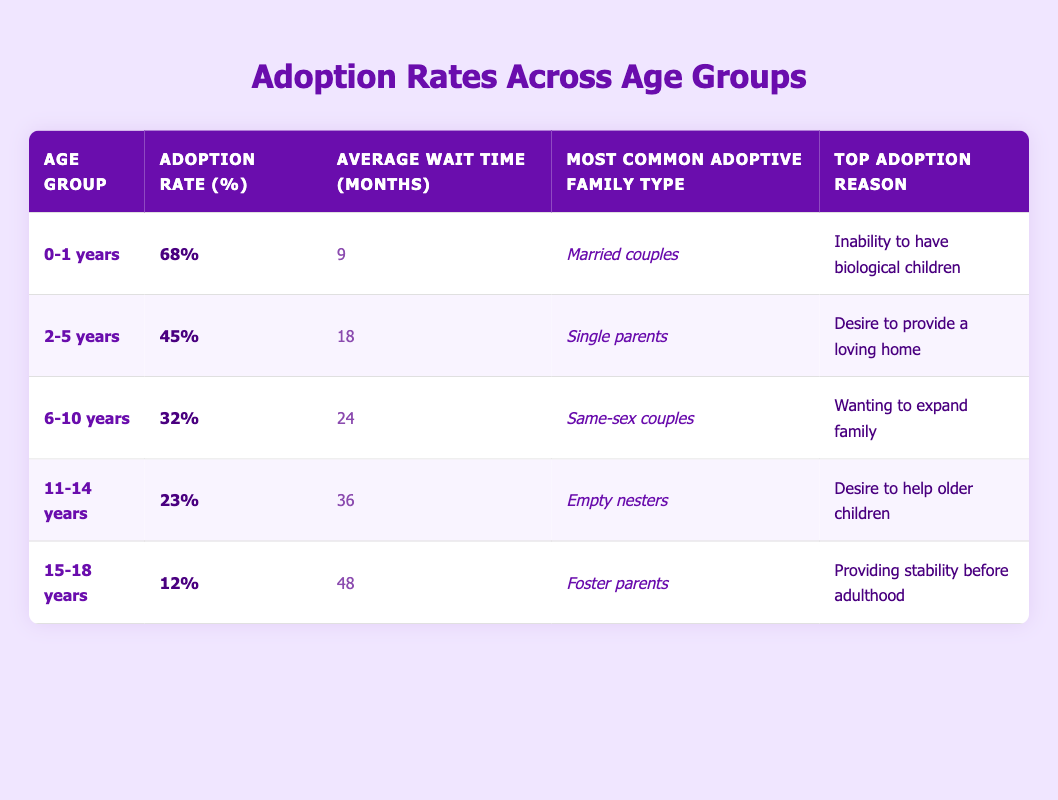What is the adoption rate for children aged 0-1 years? The adoption rate for the age group 0-1 years is shown in the table under the "Adoption Rate (%)" column in the corresponding row. It states 68%.
Answer: 68% Which age group has the highest adoption rate? By comparing the "Adoption Rate (%)" values in the table, the age group 0-1 years has the highest rate at 68%.
Answer: 0-1 years What is the average wait time for adopting a child aged 6-10 years? The table provides the "Average Wait Time (months)" for the age group 6-10 years in the corresponding row, which is 24 months.
Answer: 24 months Is the most common adoptive family type for children aged 2-5 years single parents? The table specifies the "Most Common Adoptive Family Type" for the age group 2-5 years, which lists single parents. Thus, the statement is true.
Answer: Yes Calculate the average adoption rate for children aged 11-14 years and 15-18 years. The adoption rates for these age groups are 23% for 11-14 years and 12% for 15-18 years. To find the average, sum the rates (23 + 12) = 35 and divide by the number of groups (2): 35/2 = 17.5%.
Answer: 17.5% Does the wait time increase with age? To determine this, we compare the "Average Wait Time (months)" values across all age groups. The values are: 9 months (0-1 years), 18 months (2-5 years), 24 months (6-10 years), 36 months (11-14 years), and 48 months (15-18 years). Each subsequent age group has a longer wait time, confirming the observation.
Answer: Yes What is the top adoption reason for children aged 15-18 years? The table lists the "Top Adoption Reason" for the age group 15-18 years as "Providing stability before adulthood," which can be directly found in the corresponding row.
Answer: Providing stability before adulthood How much higher is the adoption rate for children aged 0-1 years compared to those aged 11-14 years? The adoption rate for 0-1 years is 68%, while for 11-14 years it is 23%. The difference is 68 - 23 = 45 percentage points, showing that the younger age group has a significantly higher adoption rate.
Answer: 45 percentage points Which age group waits the longest for adoption? By reviewing the "Average Wait Time (months)" column, the longest wait time is associated with the age group 15-18 years, which is listed as 48 months.
Answer: 15-18 years 